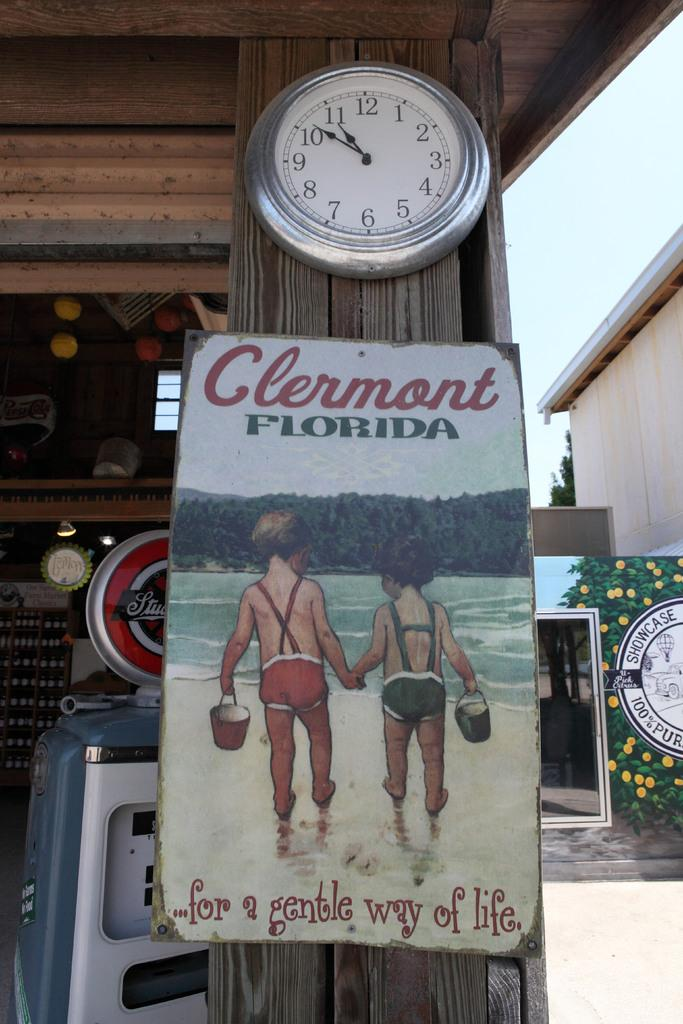<image>
Present a compact description of the photo's key features. Poster on a wooden pole which says "Clermont Florida" on it. 